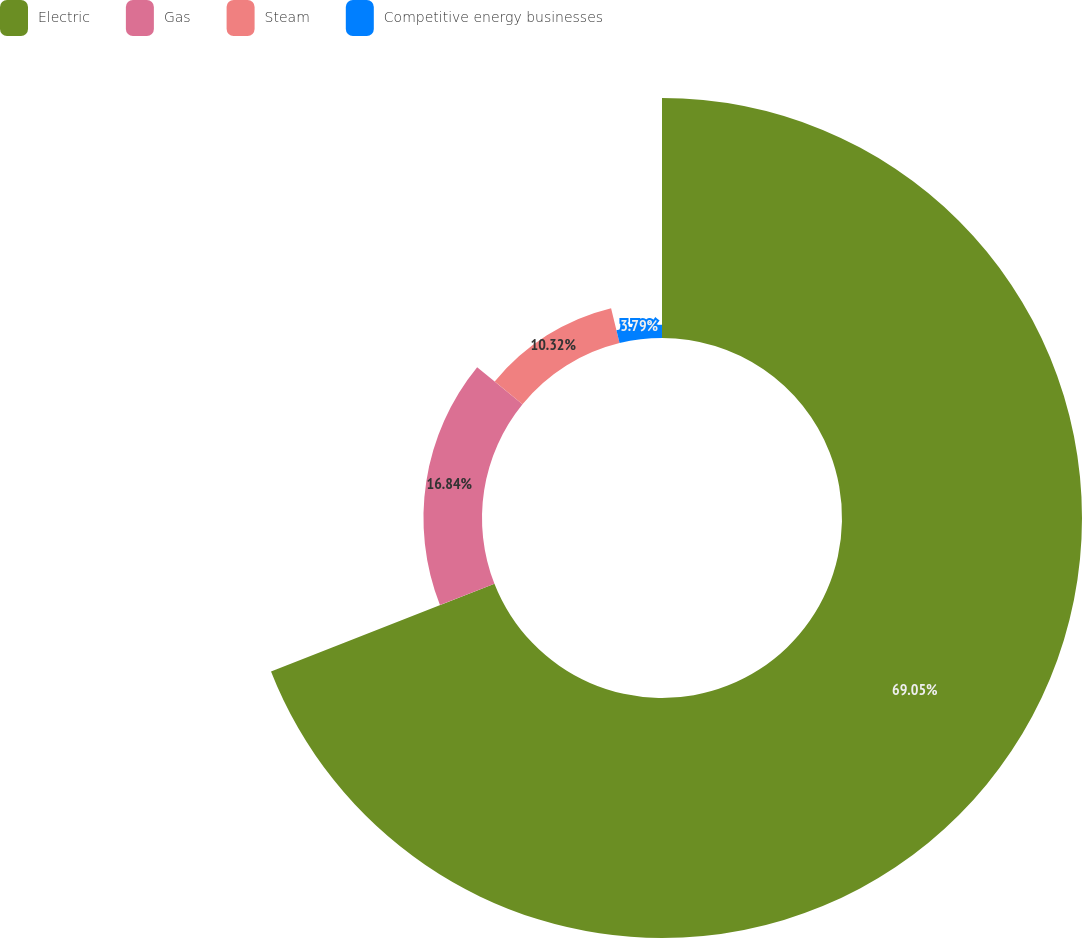<chart> <loc_0><loc_0><loc_500><loc_500><pie_chart><fcel>Electric<fcel>Gas<fcel>Steam<fcel>Competitive energy businesses<nl><fcel>69.05%<fcel>16.84%<fcel>10.32%<fcel>3.79%<nl></chart> 